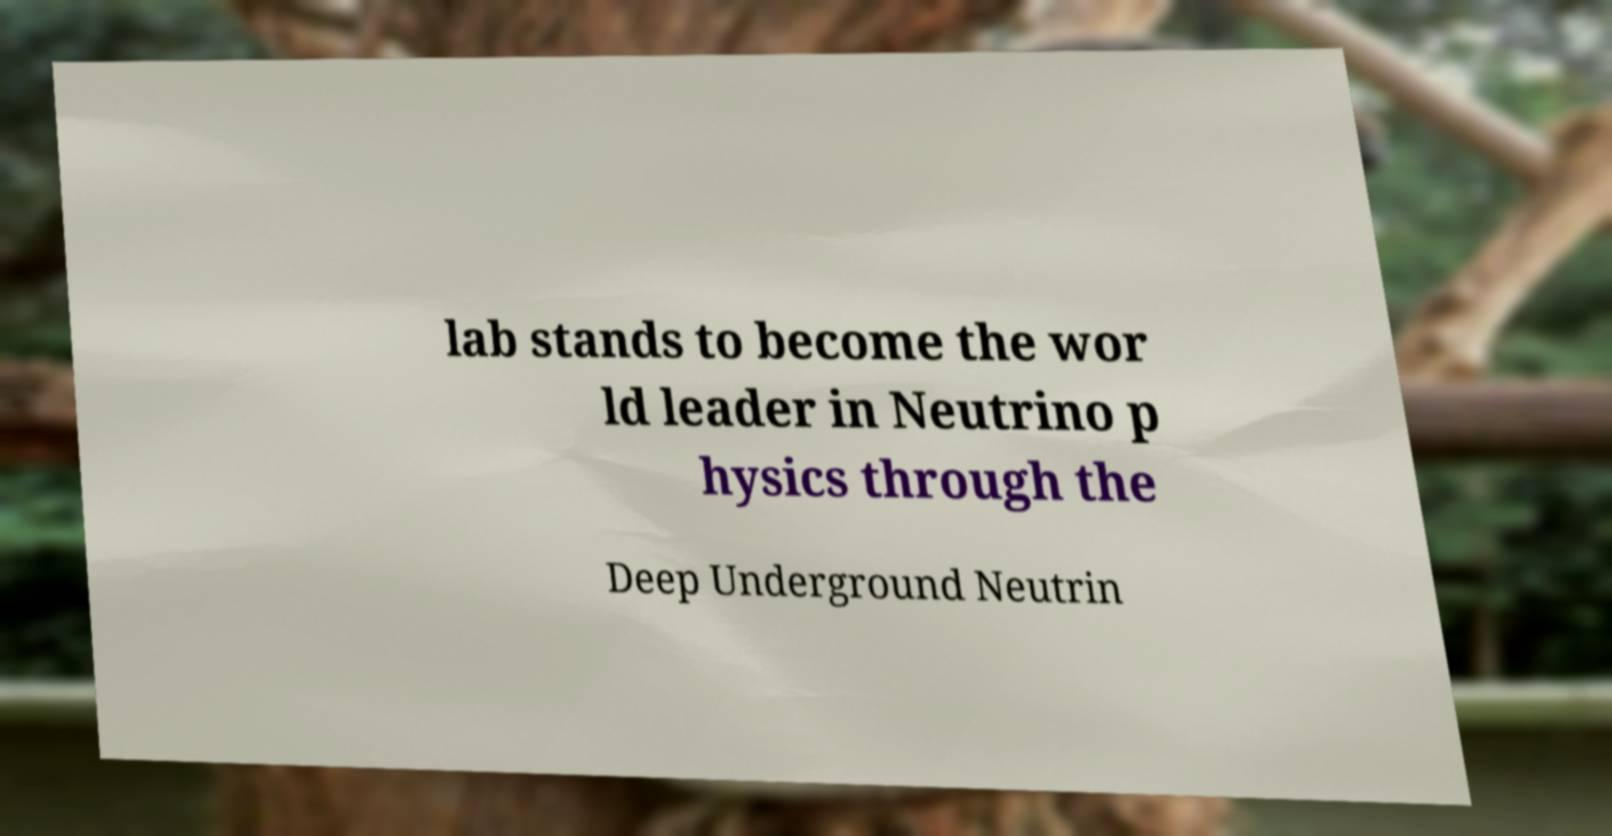Please read and relay the text visible in this image. What does it say? lab stands to become the wor ld leader in Neutrino p hysics through the Deep Underground Neutrin 